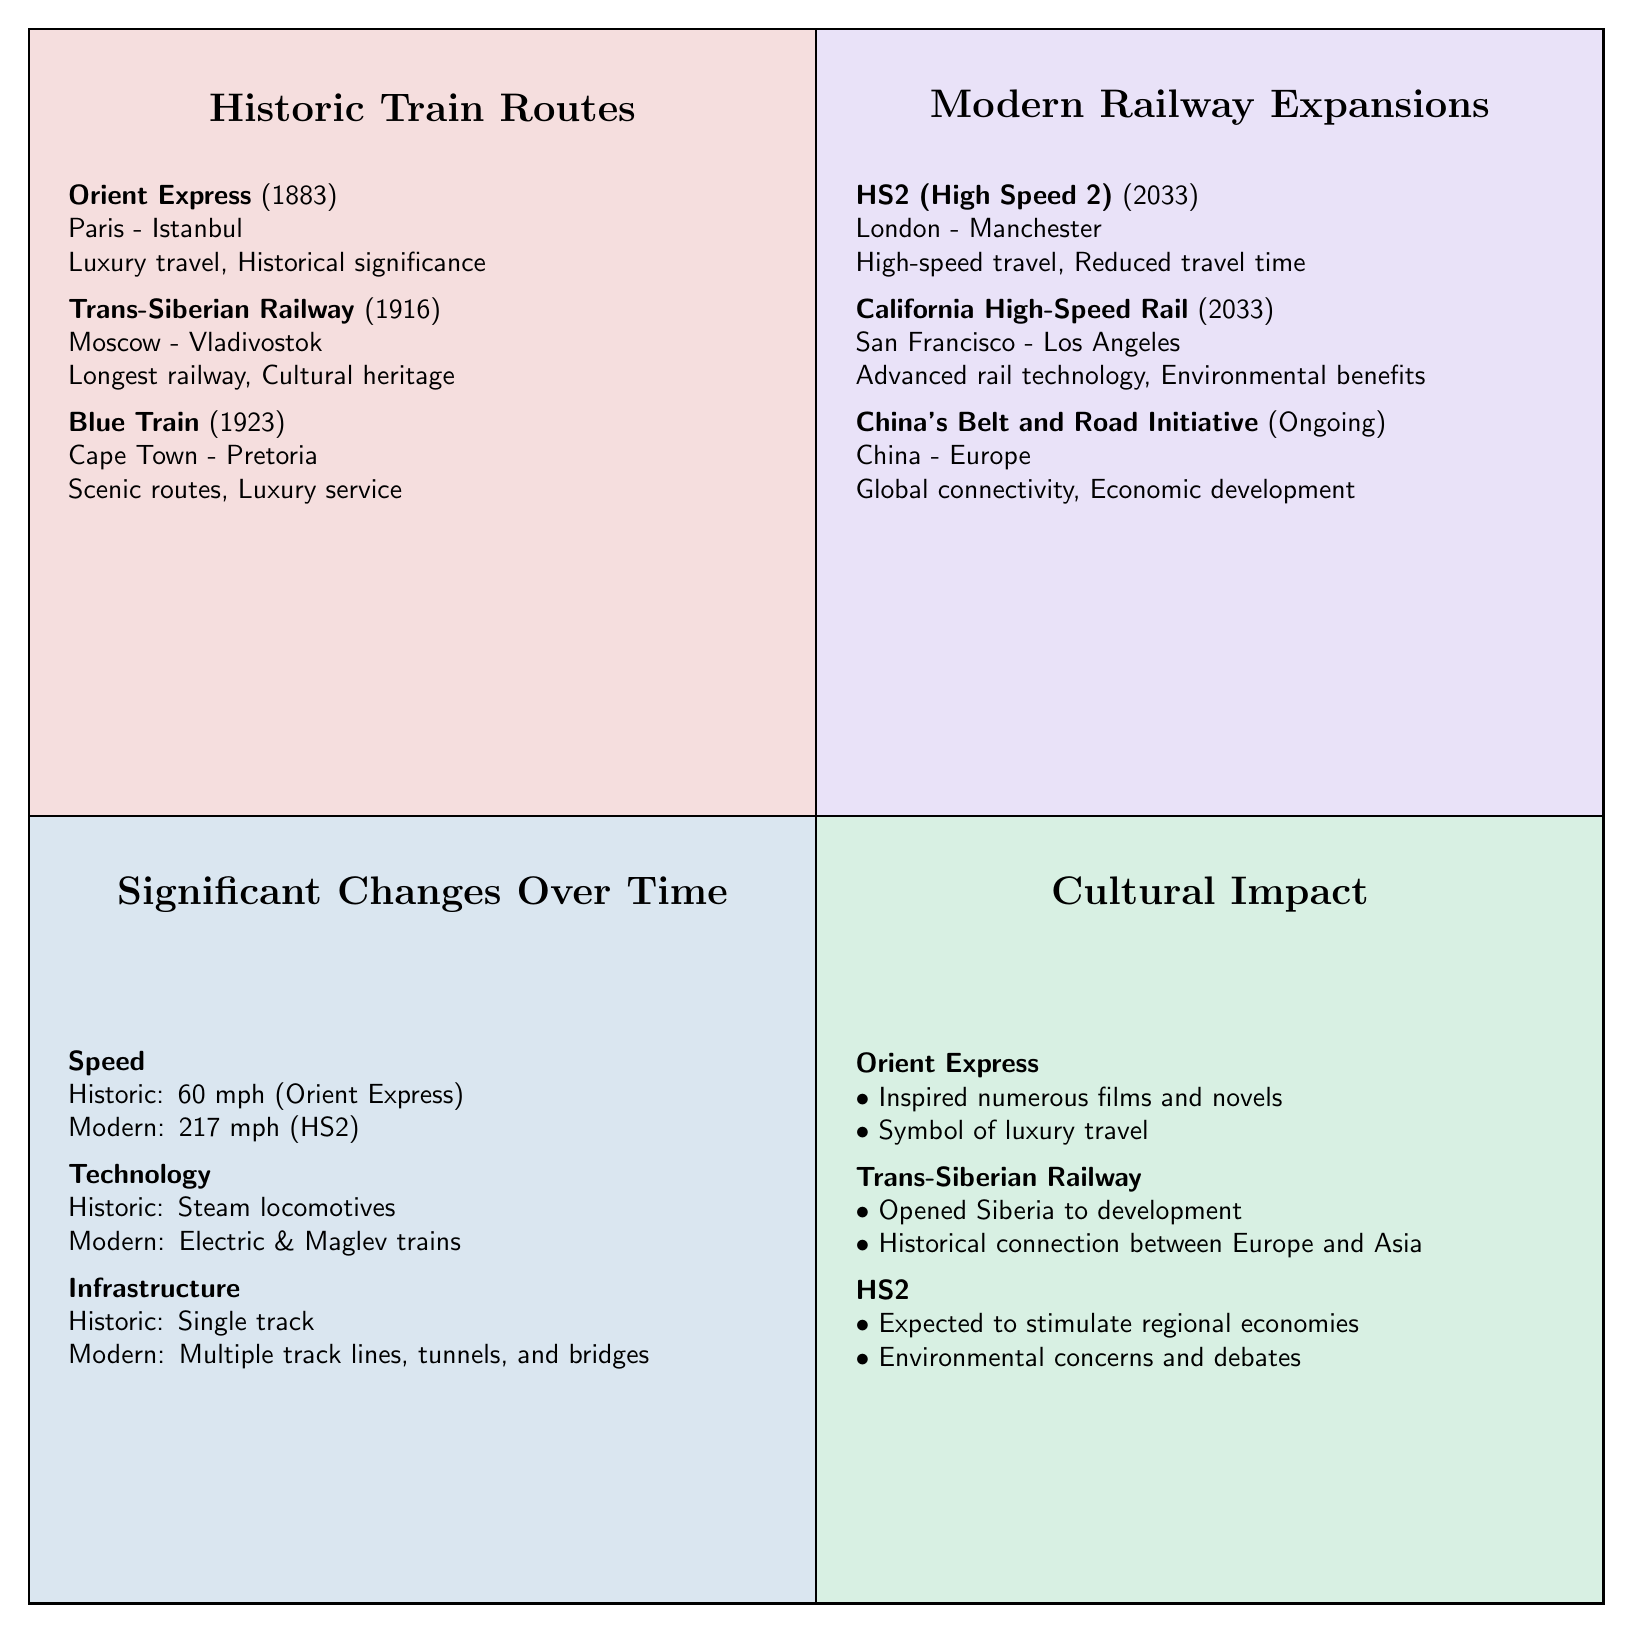What is the starting year of the Orient Express? The Orient Express, listed in the Historic Train Routes quadrant, has a start year of 1883.
Answer: 1883 How many significant changes over time are shown? The Significant Changes Over Time quadrant includes three aspects: Speed, Technology, and Infrastructure. So there are three significant changes listed.
Answer: 3 What is the terminal station for the Blue Train? The Blue Train, found in the Historic Train Routes quadrant, has terminal stations listed as Cape Town and Pretoria. The terminal station for the Blue Train specifically is Pretoria.
Answer: Pretoria Which modern expansion project uses advanced rail technology? The California High-Speed Rail project, located in the Modern Railway Expansions quadrant, is noted for its advanced rail technology as a key feature.
Answer: California High-Speed Rail What was the historic speed of the Orient Express? The Significant Changes Over Time quadrant indicates that the historic speed of the Orient Express was 60 mph.
Answer: 60 mph List one cultural impact of the Trans-Siberian Railway. The cultural impact section mentions that the Trans-Siberian Railway opened Siberia to development as one of its significant cultural impacts.
Answer: Opened Siberia to development What is the modern value of speed compared to the historic value? In the Significant Changes Over Time quadrant, the modern value for speed is 217 mph (HS2), while the historic value is 60 mph (Orient Express), highlighting a significant increase over time.
Answer: 217 mph How many projects are highlighted in the Modern Railway Expansions quadrant? The Modern Railway Expansions quadrant contains three projects: HS2 (High Speed 2), California High-Speed Rail, and China's Belt and Road Initiative - Railway, totaling three projects.
Answer: 3 What infrastructure development is noted as a change from historic to modern? The Significant Changes Over Time quadrant states that the historic infrastructure was single track, while modern infrastructure consists of multiple track lines, tunnels, and bridges.
Answer: Multiple track lines, tunnels, and bridges 